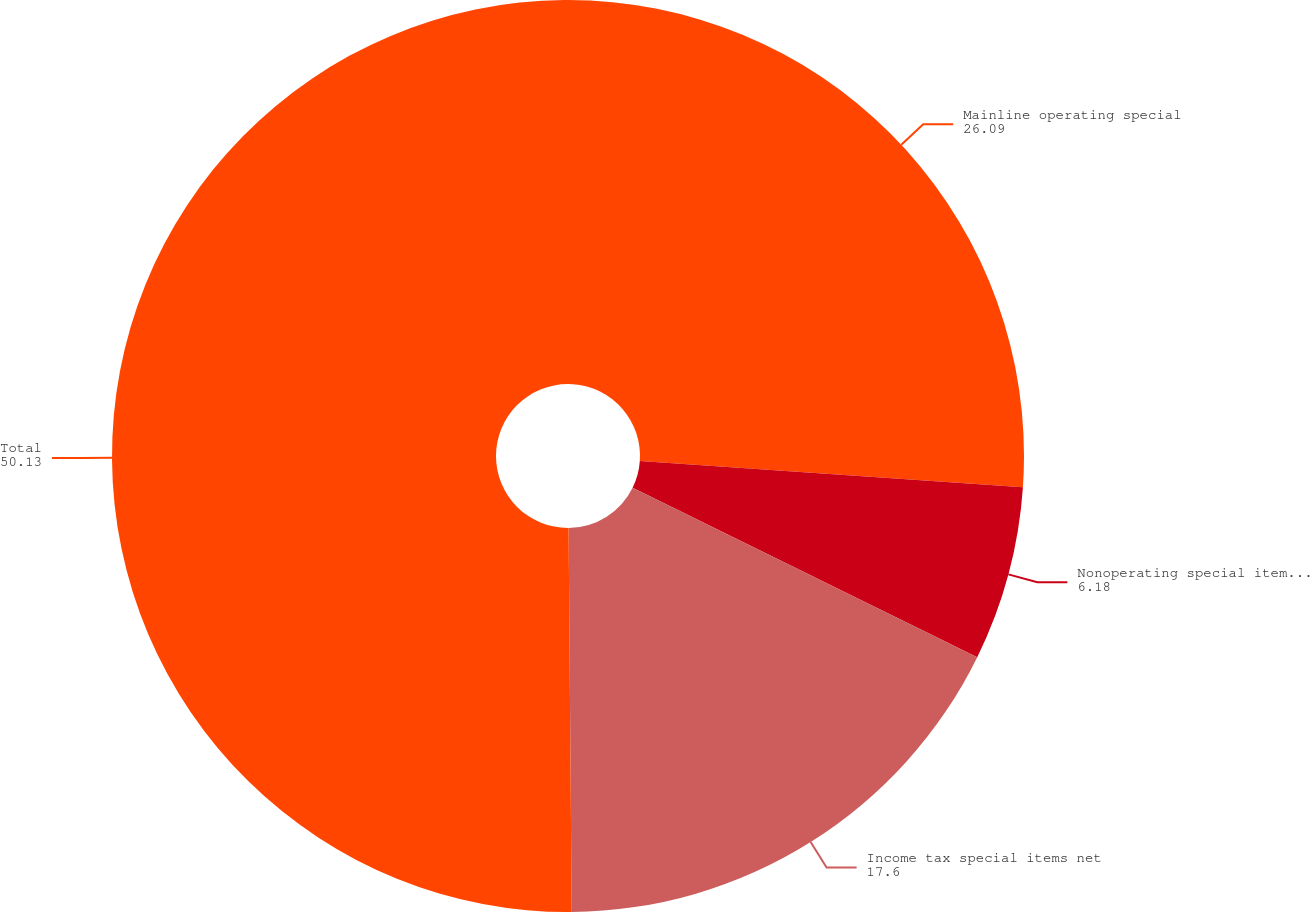Convert chart. <chart><loc_0><loc_0><loc_500><loc_500><pie_chart><fcel>Mainline operating special<fcel>Nonoperating special items net<fcel>Income tax special items net<fcel>Total<nl><fcel>26.09%<fcel>6.18%<fcel>17.6%<fcel>50.13%<nl></chart> 